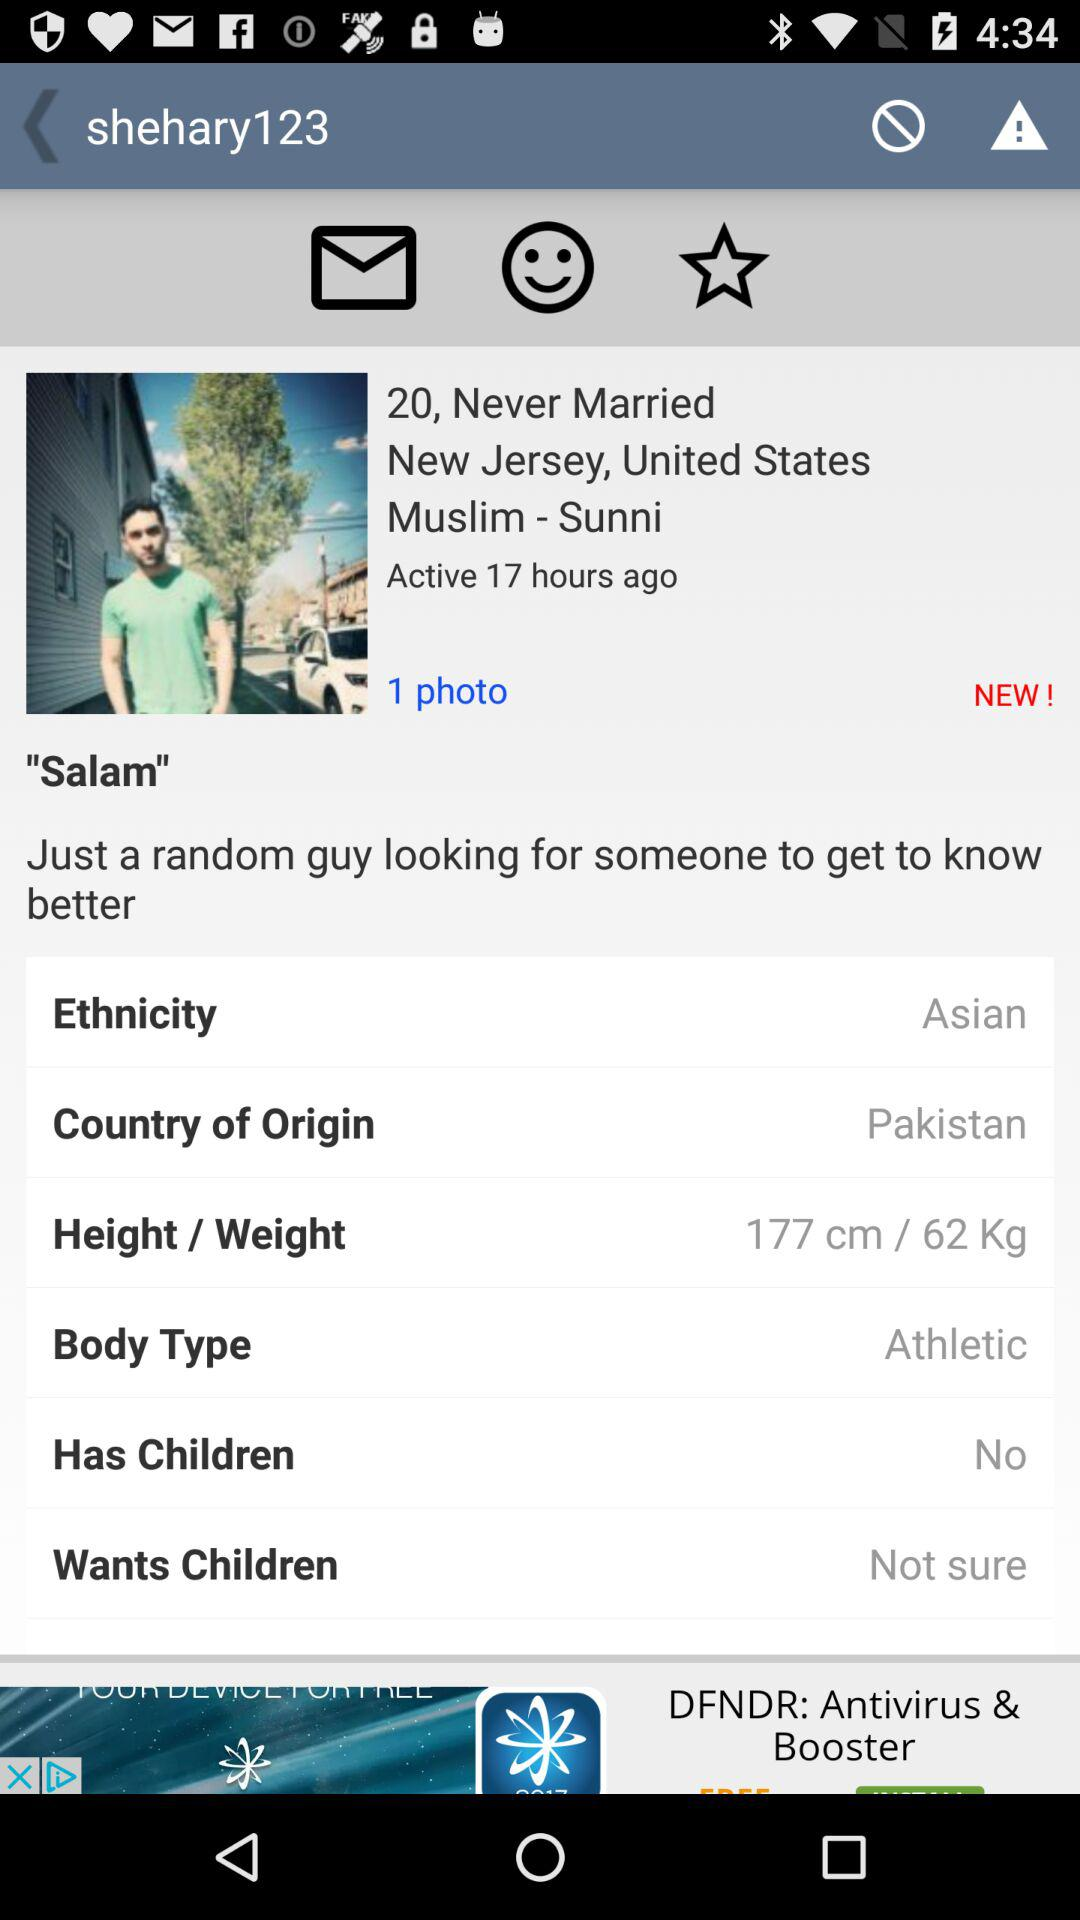What is the ethnicity? The ethnicity is "Asian". 